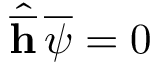<formula> <loc_0><loc_0><loc_500><loc_500>\hat { \overline { h } } \, \overline { \psi } = 0</formula> 